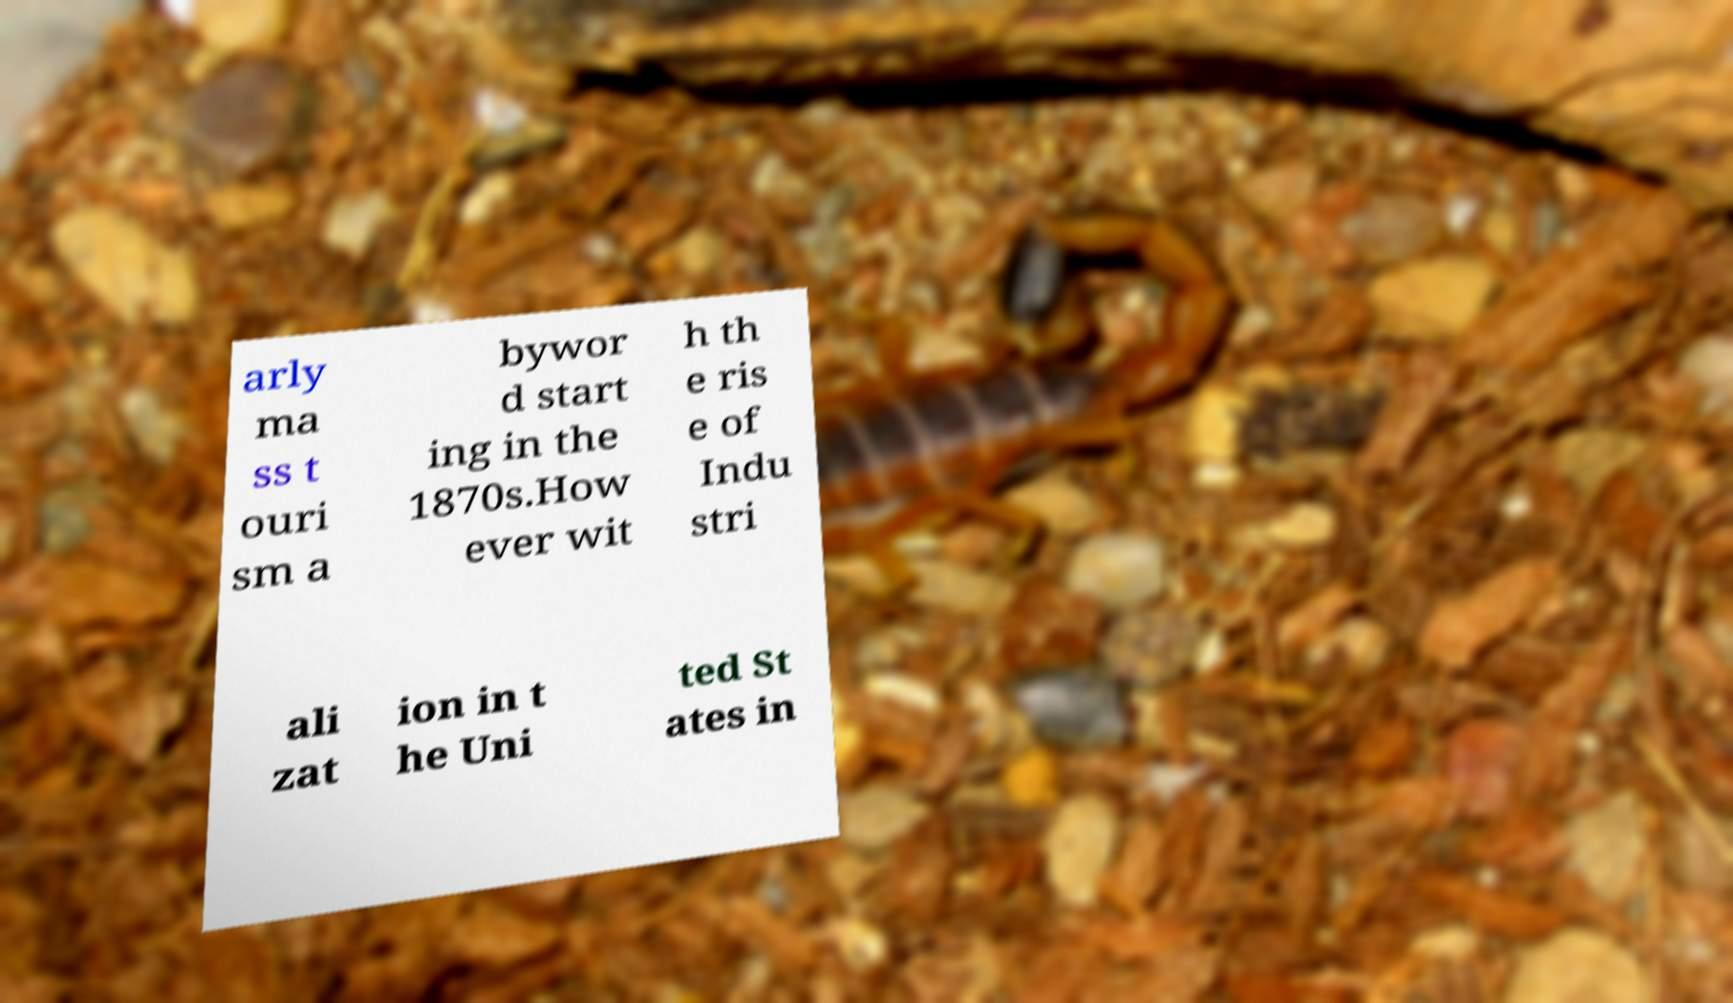There's text embedded in this image that I need extracted. Can you transcribe it verbatim? arly ma ss t ouri sm a bywor d start ing in the 1870s.How ever wit h th e ris e of Indu stri ali zat ion in t he Uni ted St ates in 